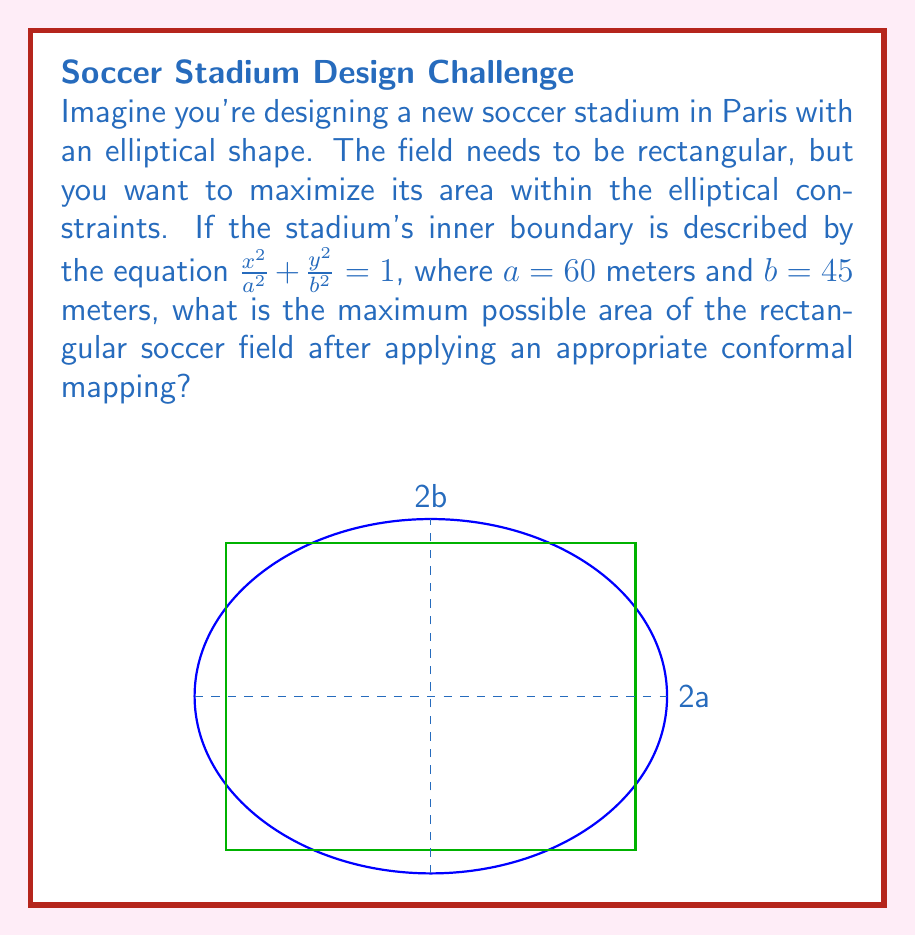Can you answer this question? Let's approach this step-by-step:

1) The ellipse is given by the equation $\frac{x^2}{a^2} + \frac{y^2}{b^2} = 1$, where $a = 60$ and $b = 45$.

2) To maximize the rectangular area within this ellipse, we can use a conformal mapping to transform the ellipse into a circle. The Joukowski transformation is appropriate for this:

   $w = \frac{z}{k}$, where $k = \sqrt{\frac{a+b}{2}}$

3) Calculate $k$:
   $k = \sqrt{\frac{60+45}{2}} = \sqrt{52.5} \approx 7.246$

4) After this transformation, our ellipse becomes a circle with radius $R$:
   $R = \frac{a+b}{2k} = \frac{60+45}{2(7.246)} \approx 7.246$

5) In the circular domain, the maximum inscribed rectangle is a square with side length $\frac{2R}{\sqrt{2}}$.

6) The area of this square in the w-plane is:
   $A_w = (\frac{2R}{\sqrt{2}})^2 = 2R^2 \approx 105.06$

7) To find the area in the original z-plane (our stadium), we need to apply the inverse of the area scaling factor. The area scaling factor of the Joukowski transformation is $|\frac{dw}{dz}|^2 = \frac{1}{k^2}$.

8) Therefore, the maximum area in the original plane is:
   $A_z = A_w \cdot k^2 = 105.06 \cdot 7.246^2 \approx 5,509.89$ square meters
Answer: $5,509.89 \text{ m}^2$ 